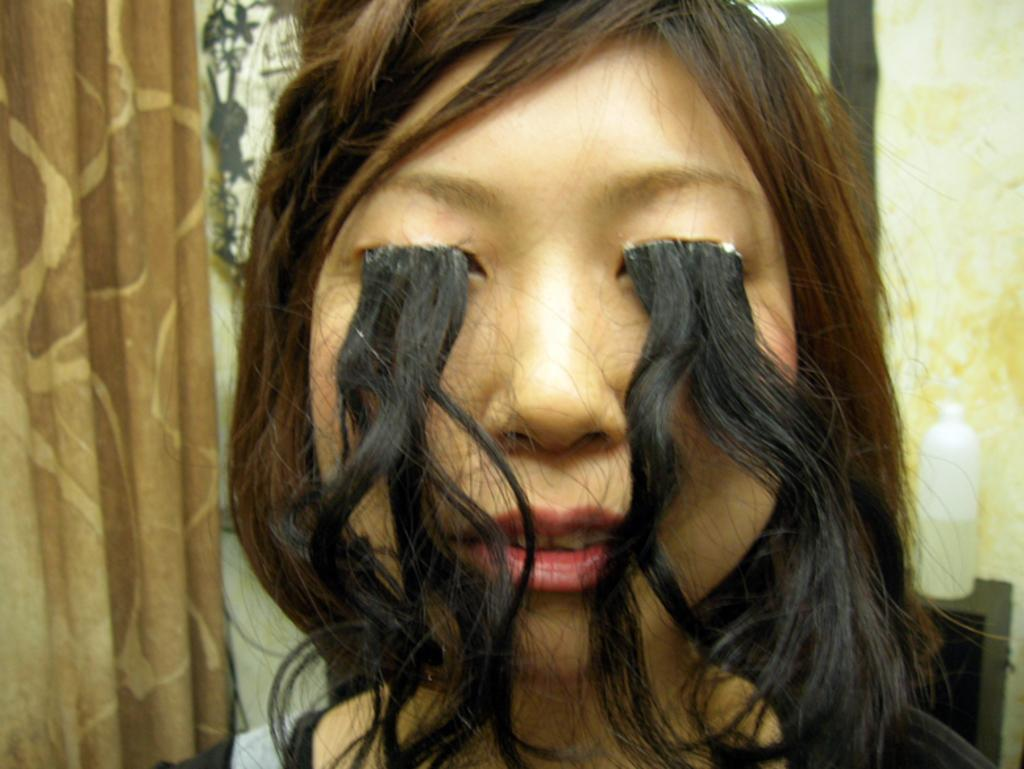Who is present in the image? There is a woman in the image. What can be observed about the woman's appearance? The woman has hair. What is visible in the background of the image? There is a wall, a bottle on a platform, and a curtain in the background of the image. What type of education can be seen in the image? There is no indication of education in the image; it features a woman with hair and a background with a wall, a bottle on a platform, and a curtain. 